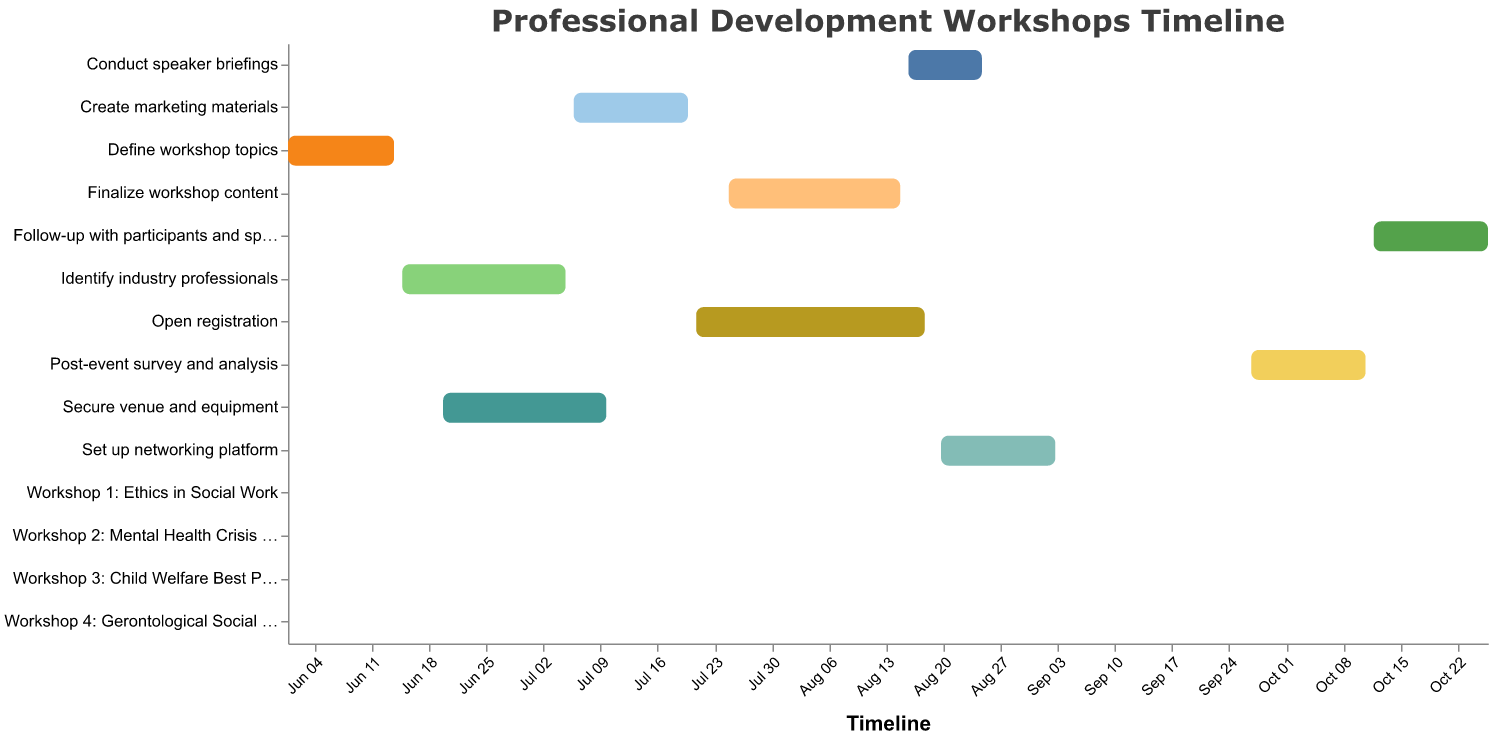What is the title of the chart? The title of the chart is typically located at the top center of the figure. It summarizes the main focus or subject of the chart.
Answer: Professional Development Workshops Timeline Which task has the shortest duration? To find the task with the shortest duration, you compare the duration values of all the tasks. The task with the value "1" indicates it is the shortest.
Answer: Workshop 1: Ethics in Social Work, Workshop 2: Mental Health Crisis Intervention, Workshop 3: Child Welfare Best Practices, Workshop 4: Gerontological Social Work What is the duration for securing venue and equipment? Look for the task named "Secure venue and equipment" and refer to its associated duration.
Answer: 21 days Which tasks overlap in their timelines? To identify overlapping tasks, compare the start and end dates of different tasks and see if their timelines intersect.
Answer: Identify industry professionals, Secure venue and equipment When does the "Create marketing materials" task end? Locate the "Create marketing materials" task and find its end date value.
Answer: 2023-07-20 What is the total duration of "Post-event survey and analysis" and "Follow-up with participants and speakers"? Add the duration values of "Post-event survey and analysis" and "Follow-up with participants and speakers" together: 15 + 15.
Answer: 30 days Which task directly follows the "Workshop 4: Gerontological Social Work" in the timeline? Check the timeline to see which task begins immediately after "Workshop 4: Gerontological Social Work".
Answer: Post-event survey and analysis How many days are there between when "Finalize workshop content" ends and "Workshop 1: Ethics in Social Work" begins? Calculate the days between the end date of "Finalize workshop content" (2023-08-15) and the start date of "Workshop 1: Ethics in Social Work" (2023-09-05).
Answer: 21 days What is the longest task in the timeline? Compare the duration values of all tasks and identify the task with the highest duration value.
Answer: Open registration 